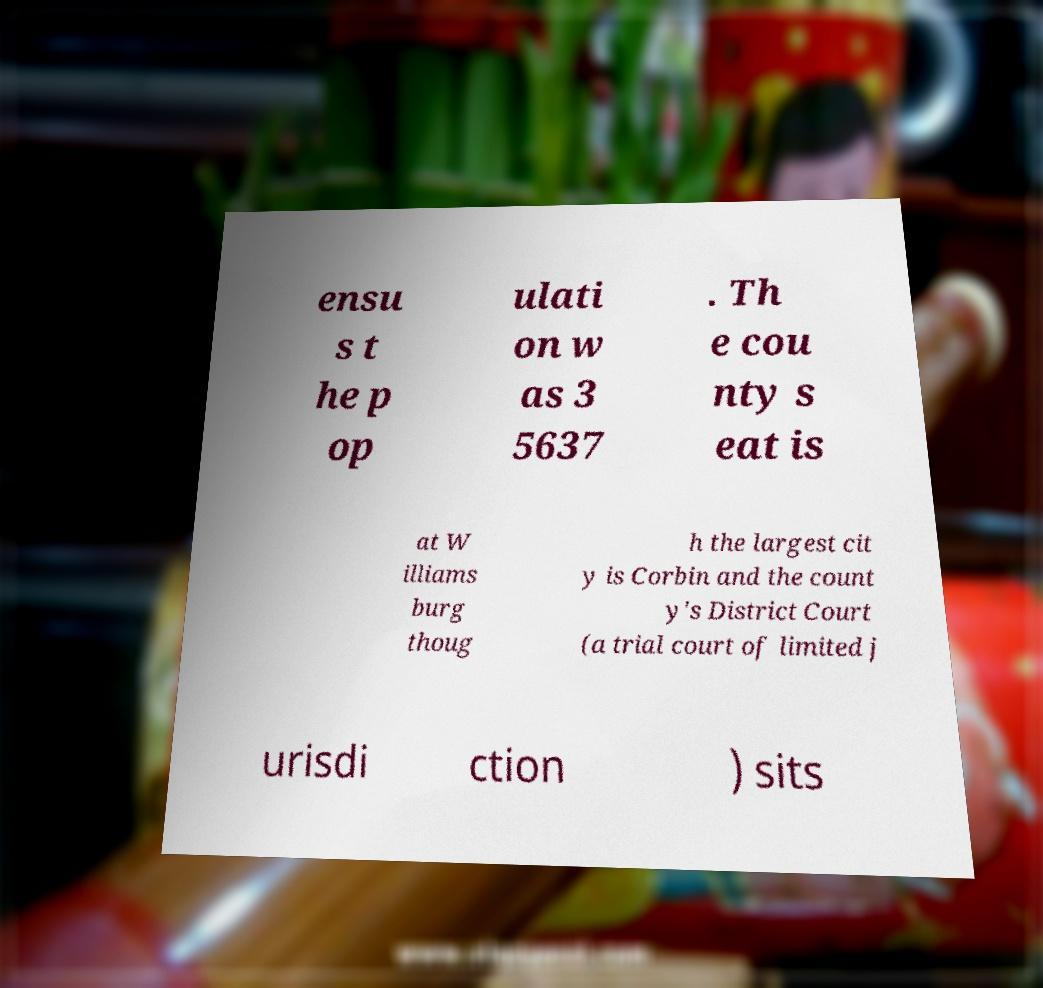Could you extract and type out the text from this image? ensu s t he p op ulati on w as 3 5637 . Th e cou nty s eat is at W illiams burg thoug h the largest cit y is Corbin and the count y's District Court (a trial court of limited j urisdi ction ) sits 